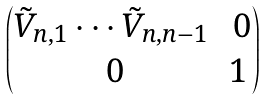<formula> <loc_0><loc_0><loc_500><loc_500>\begin{pmatrix} \tilde { V } _ { n , 1 } \cdots \tilde { V } _ { n , n - 1 } & \ 0 \\ \ 0 & 1 \end{pmatrix}</formula> 